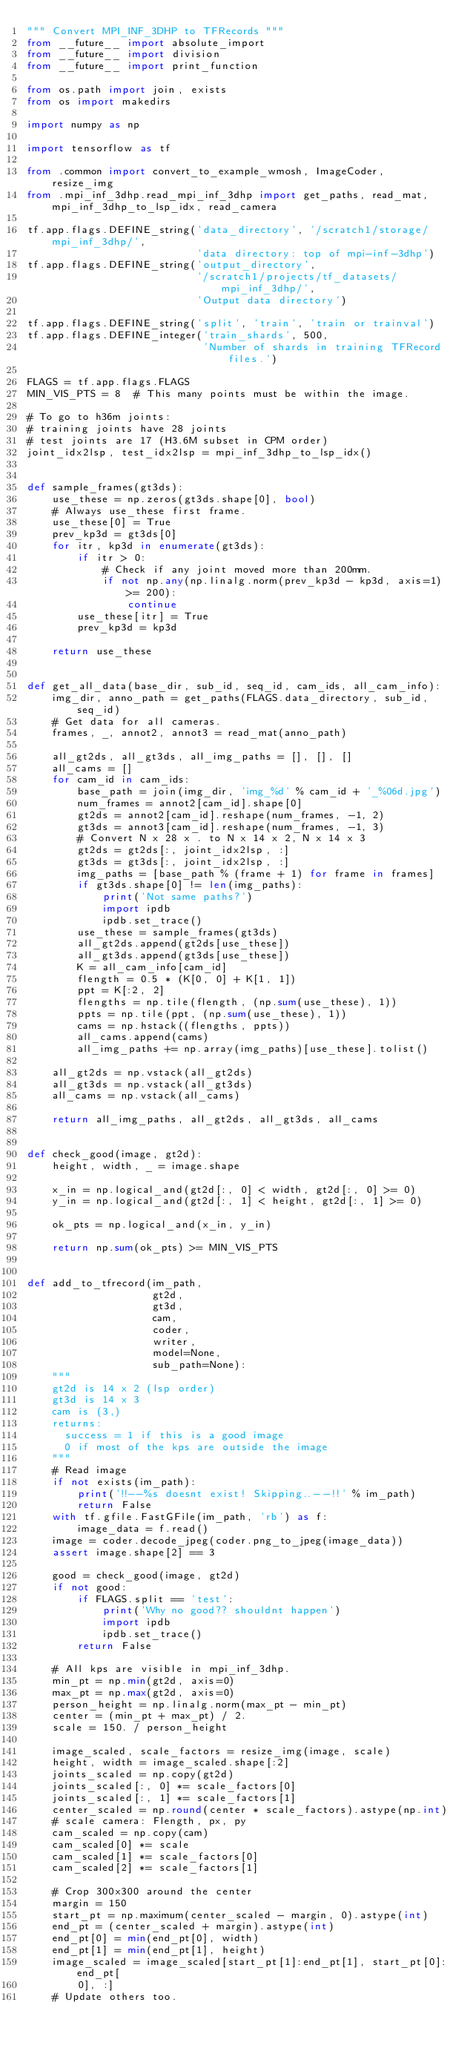<code> <loc_0><loc_0><loc_500><loc_500><_Python_>""" Convert MPI_INF_3DHP to TFRecords """
from __future__ import absolute_import
from __future__ import division
from __future__ import print_function

from os.path import join, exists
from os import makedirs

import numpy as np

import tensorflow as tf

from .common import convert_to_example_wmosh, ImageCoder, resize_img
from .mpi_inf_3dhp.read_mpi_inf_3dhp import get_paths, read_mat, mpi_inf_3dhp_to_lsp_idx, read_camera

tf.app.flags.DEFINE_string('data_directory', '/scratch1/storage/mpi_inf_3dhp/',
                           'data directory: top of mpi-inf-3dhp')
tf.app.flags.DEFINE_string('output_directory',
                           '/scratch1/projects/tf_datasets/mpi_inf_3dhp/',
                           'Output data directory')

tf.app.flags.DEFINE_string('split', 'train', 'train or trainval')
tf.app.flags.DEFINE_integer('train_shards', 500,
                            'Number of shards in training TFRecord files.')

FLAGS = tf.app.flags.FLAGS
MIN_VIS_PTS = 8  # This many points must be within the image.

# To go to h36m joints:
# training joints have 28 joints
# test joints are 17 (H3.6M subset in CPM order)
joint_idx2lsp, test_idx2lsp = mpi_inf_3dhp_to_lsp_idx()


def sample_frames(gt3ds):
    use_these = np.zeros(gt3ds.shape[0], bool)
    # Always use_these first frame.
    use_these[0] = True
    prev_kp3d = gt3ds[0]
    for itr, kp3d in enumerate(gt3ds):
        if itr > 0:
            # Check if any joint moved more than 200mm.
            if not np.any(np.linalg.norm(prev_kp3d - kp3d, axis=1) >= 200):
                continue
        use_these[itr] = True
        prev_kp3d = kp3d

    return use_these


def get_all_data(base_dir, sub_id, seq_id, cam_ids, all_cam_info):
    img_dir, anno_path = get_paths(FLAGS.data_directory, sub_id, seq_id)
    # Get data for all cameras.
    frames, _, annot2, annot3 = read_mat(anno_path)

    all_gt2ds, all_gt3ds, all_img_paths = [], [], []
    all_cams = []
    for cam_id in cam_ids:
        base_path = join(img_dir, 'img_%d' % cam_id + '_%06d.jpg')
        num_frames = annot2[cam_id].shape[0]
        gt2ds = annot2[cam_id].reshape(num_frames, -1, 2)
        gt3ds = annot3[cam_id].reshape(num_frames, -1, 3)
        # Convert N x 28 x . to N x 14 x 2, N x 14 x 3
        gt2ds = gt2ds[:, joint_idx2lsp, :]
        gt3ds = gt3ds[:, joint_idx2lsp, :]
        img_paths = [base_path % (frame + 1) for frame in frames]
        if gt3ds.shape[0] != len(img_paths):
            print('Not same paths?')
            import ipdb
            ipdb.set_trace()
        use_these = sample_frames(gt3ds)
        all_gt2ds.append(gt2ds[use_these])
        all_gt3ds.append(gt3ds[use_these])
        K = all_cam_info[cam_id]
        flength = 0.5 * (K[0, 0] + K[1, 1])
        ppt = K[:2, 2]
        flengths = np.tile(flength, (np.sum(use_these), 1))
        ppts = np.tile(ppt, (np.sum(use_these), 1))
        cams = np.hstack((flengths, ppts))
        all_cams.append(cams)
        all_img_paths += np.array(img_paths)[use_these].tolist()

    all_gt2ds = np.vstack(all_gt2ds)
    all_gt3ds = np.vstack(all_gt3ds)
    all_cams = np.vstack(all_cams)

    return all_img_paths, all_gt2ds, all_gt3ds, all_cams


def check_good(image, gt2d):
    height, width, _ = image.shape

    x_in = np.logical_and(gt2d[:, 0] < width, gt2d[:, 0] >= 0)
    y_in = np.logical_and(gt2d[:, 1] < height, gt2d[:, 1] >= 0)

    ok_pts = np.logical_and(x_in, y_in)

    return np.sum(ok_pts) >= MIN_VIS_PTS


def add_to_tfrecord(im_path,
                    gt2d,
                    gt3d,
                    cam,
                    coder,
                    writer,
                    model=None,
                    sub_path=None):
    """
    gt2d is 14 x 2 (lsp order)
    gt3d is 14 x 3
    cam is (3,)
    returns:
      success = 1 if this is a good image
      0 if most of the kps are outside the image
    """
    # Read image
    if not exists(im_path):
        print('!!--%s doesnt exist! Skipping..--!!' % im_path)
        return False
    with tf.gfile.FastGFile(im_path, 'rb') as f:
        image_data = f.read()
    image = coder.decode_jpeg(coder.png_to_jpeg(image_data))
    assert image.shape[2] == 3

    good = check_good(image, gt2d)
    if not good:
        if FLAGS.split == 'test':
            print('Why no good?? shouldnt happen')
            import ipdb
            ipdb.set_trace()
        return False

    # All kps are visible in mpi_inf_3dhp.
    min_pt = np.min(gt2d, axis=0)
    max_pt = np.max(gt2d, axis=0)
    person_height = np.linalg.norm(max_pt - min_pt)
    center = (min_pt + max_pt) / 2.
    scale = 150. / person_height

    image_scaled, scale_factors = resize_img(image, scale)
    height, width = image_scaled.shape[:2]
    joints_scaled = np.copy(gt2d)
    joints_scaled[:, 0] *= scale_factors[0]
    joints_scaled[:, 1] *= scale_factors[1]
    center_scaled = np.round(center * scale_factors).astype(np.int)
    # scale camera: Flength, px, py
    cam_scaled = np.copy(cam)
    cam_scaled[0] *= scale
    cam_scaled[1] *= scale_factors[0]
    cam_scaled[2] *= scale_factors[1]

    # Crop 300x300 around the center
    margin = 150
    start_pt = np.maximum(center_scaled - margin, 0).astype(int)
    end_pt = (center_scaled + margin).astype(int)
    end_pt[0] = min(end_pt[0], width)
    end_pt[1] = min(end_pt[1], height)
    image_scaled = image_scaled[start_pt[1]:end_pt[1], start_pt[0]:end_pt[
        0], :]
    # Update others too.</code> 